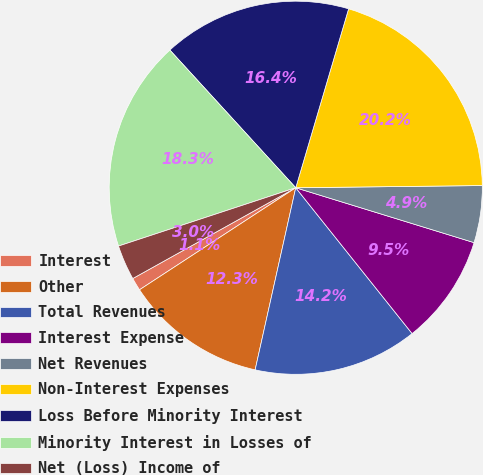<chart> <loc_0><loc_0><loc_500><loc_500><pie_chart><fcel>Interest<fcel>Other<fcel>Total Revenues<fcel>Interest Expense<fcel>Net Revenues<fcel>Non-Interest Expenses<fcel>Loss Before Minority Interest<fcel>Minority Interest in Losses of<fcel>Net (Loss) Income of<nl><fcel>1.12%<fcel>12.3%<fcel>14.21%<fcel>9.53%<fcel>4.94%<fcel>20.24%<fcel>16.36%<fcel>18.27%<fcel>3.03%<nl></chart> 